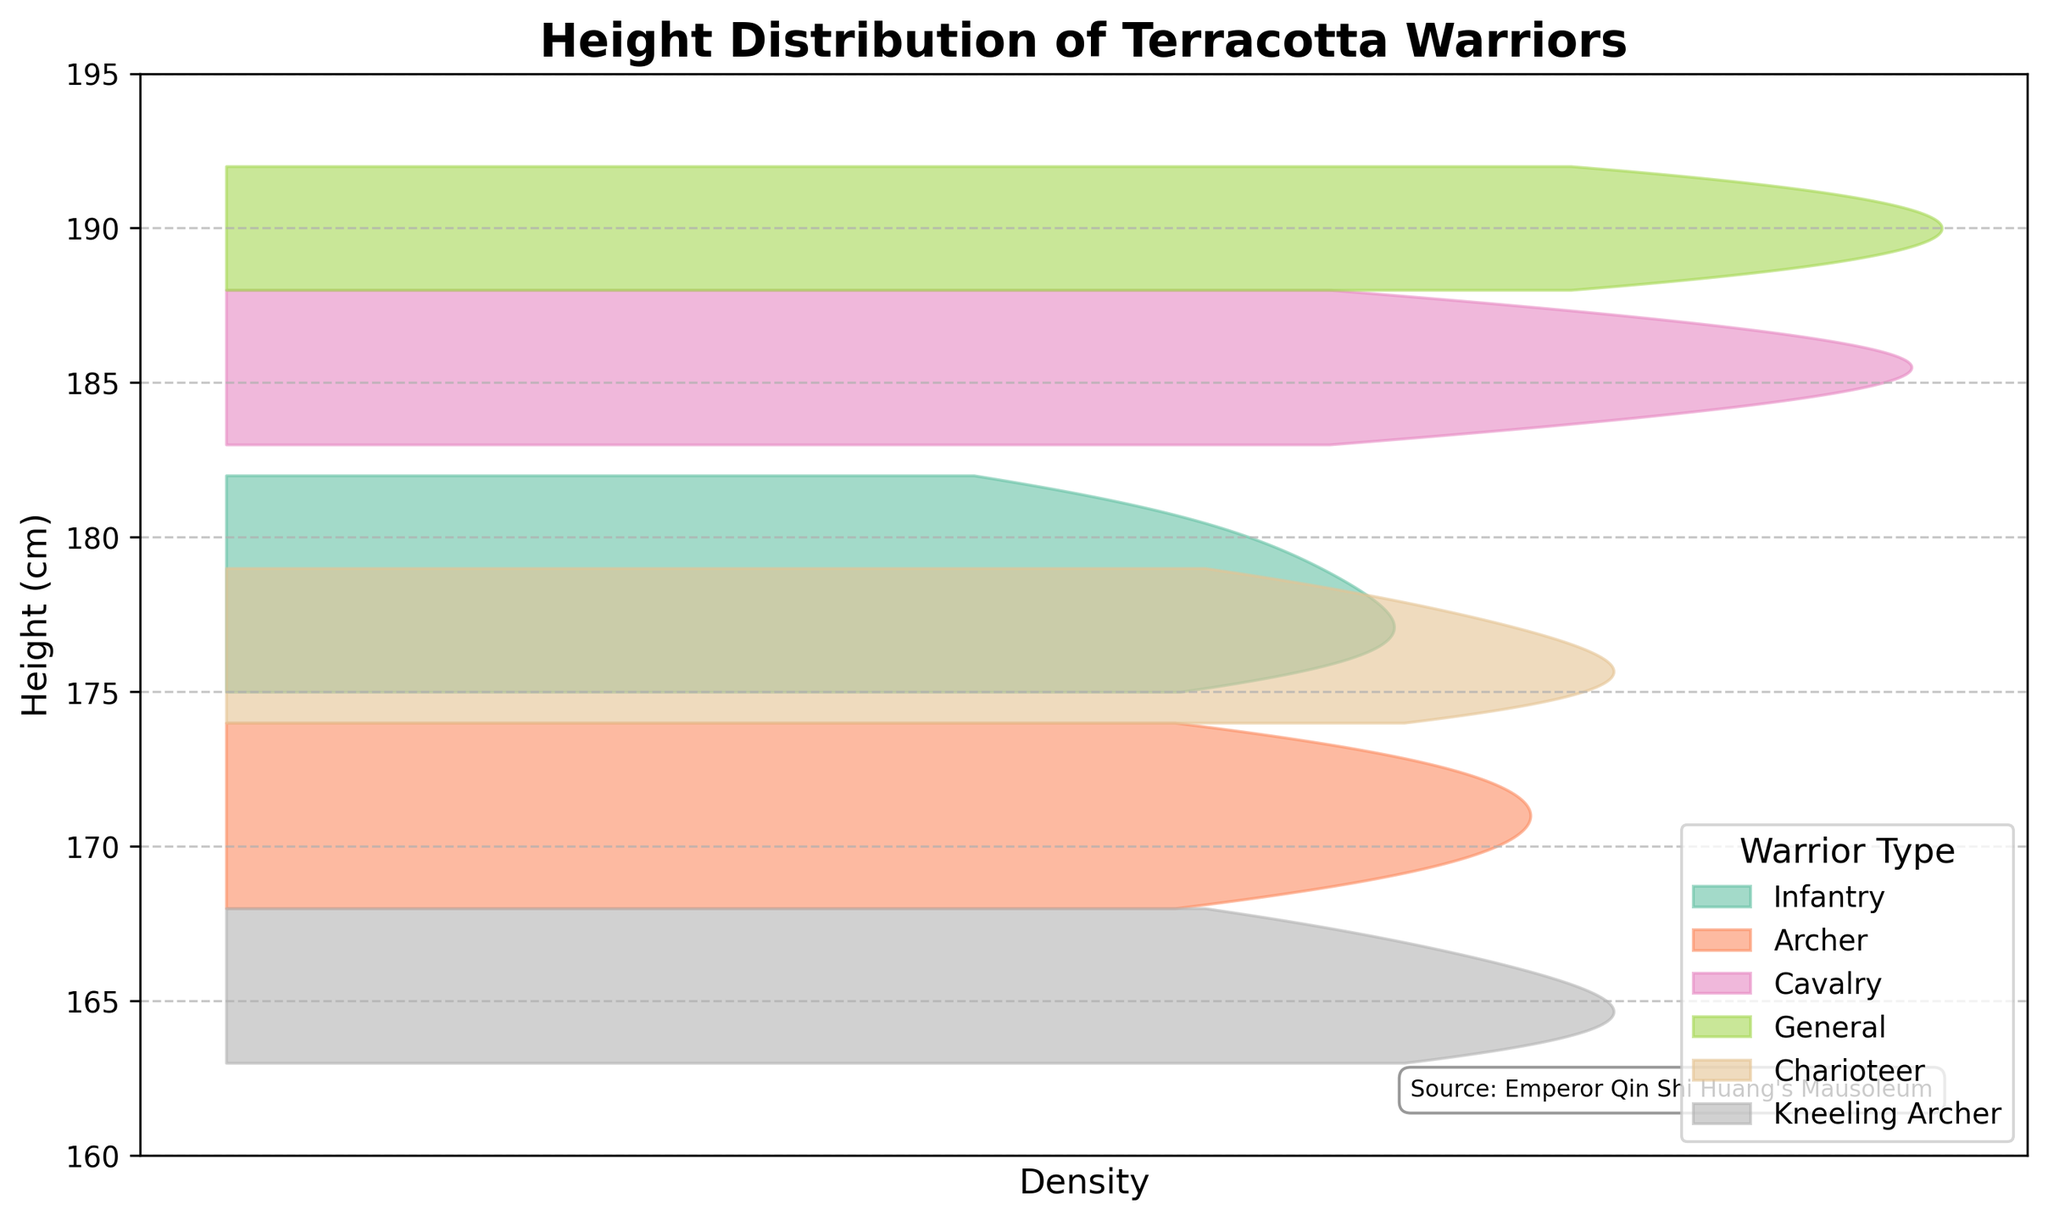What is the range of heights for the infantry warriors? The infantry warriors' heights range from 175 cm to 182 cm. This can be seen from the plot where the distribution of heights extends from the lowest to the highest value.
Answer: 175 cm to 182 cm Which type of warrior has the tallest average height? The general warriors have the tallest average height. This can be inferred from the density plot where the distribution for the generals is centered around the higher values compared to other types.
Answer: General Are the cavalry warriors taller on average than the archers? Yes, the density plot shows that the peak of the cavalry warriors' height distribution is at a higher value than that of the archers.
Answer: Yes What is the height range for the kneeling archers? The height range for kneeling archers extends from 163 cm to 168 cm, as indicated by the distribution on the plot.
Answer: 163 cm to 168 cm Do any warrior types have overlapping height distributions on the plot? Yes, the height distributions of the charioteers, infantry, and archers overlap with each other. This can be observed from the overlapping sections of their density curves.
Answer: Yes What is the common height range that both infantry and charioteer warriors share? Both infantry and charioteer warriors share a common height range from 174 cm to 176 cm, seen from the overlapping areas in their density curves.
Answer: 174 cm to 176 cm Compare the height ranges of generals and archers. The generals have a height range from 188 cm to 192 cm, while the archers range from 168 cm to 174 cm. Generals are on average taller than archers, suggested by the non-overlapping plots and the distinct difference in center values.
Answer: Generals are taller, ranges: 188-192 cm (generals), 168-174 cm (archers) What percentage of the total plotted area does the cavalry density plot take up compared to the kneeling archer's density plot? To estimate the percentage visually, observe that the cavalry warriors' density plot is substantially narrower with the highest peaks, while the kneeling archer's density plot covers a wider, more spread-out area. Therefore, the cavalry warriors' density plot likely occupies a higher peak area but a smaller overall range percentage visually compared to kneeling archers.
Answer: Cavalry takes a smaller visual percentage 